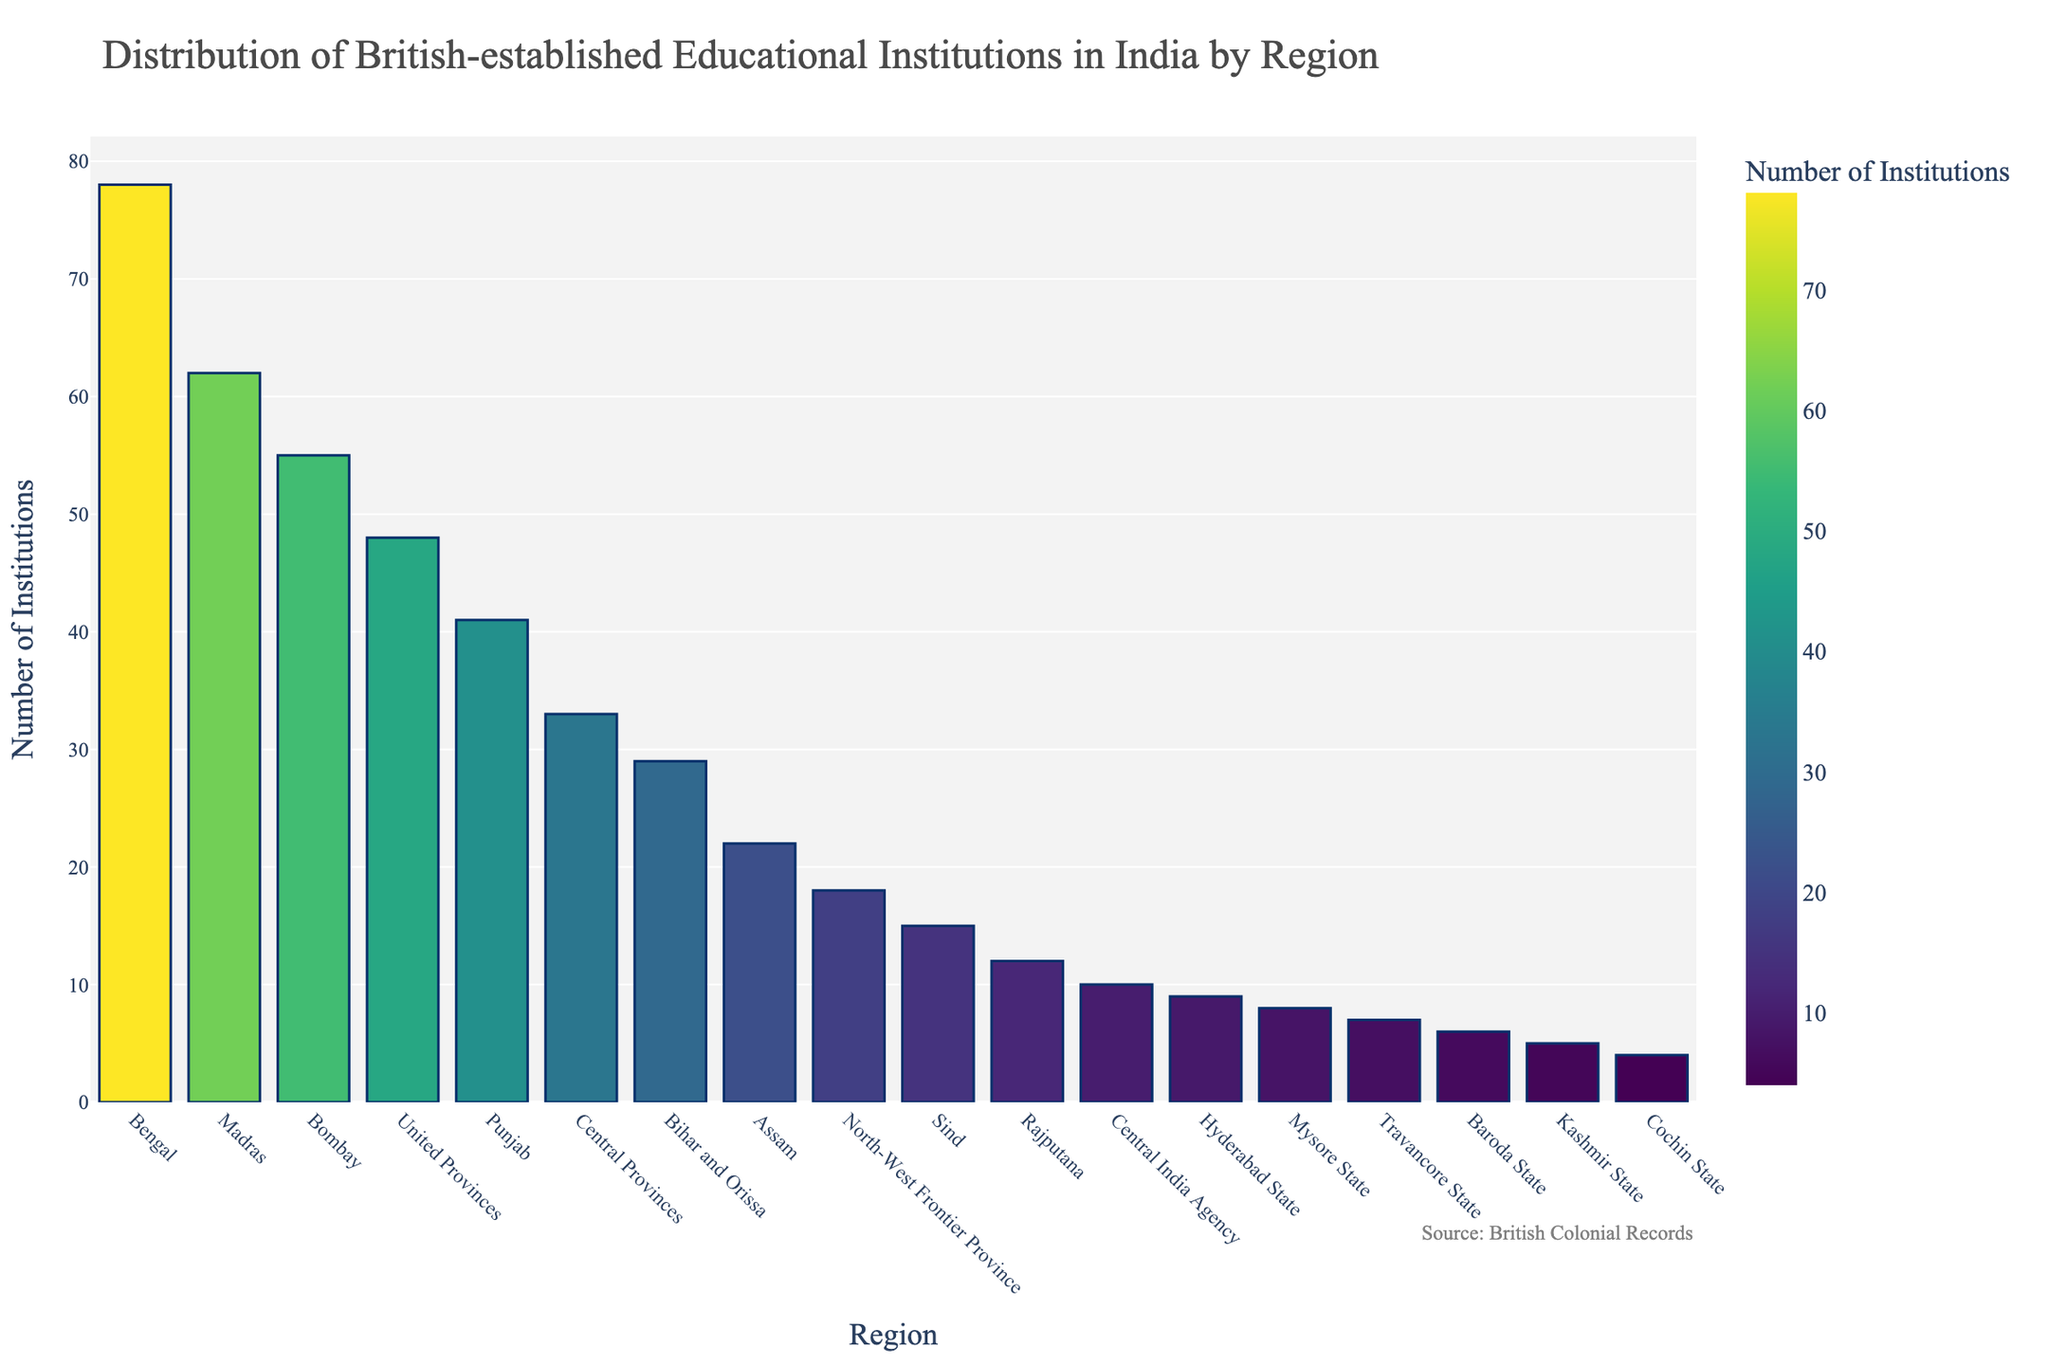Which region has the highest number of British-established educational institutions? To determine the region with the highest number of institutions, look at the bar chart and identify the tallest bar. The tallest bar represents the Bengal region.
Answer: Bengal Which region has the lowest number of British-established educational institutions? To find the region with the lowest number of institutions, identify the shortest bar on the chart. The shortest bar represents the Cochin State.
Answer: Cochin State How many more institutions does Bengal have compared to Punjab? Subtract the number of institutions in Punjab from the number in Bengal. Bengal has 78 institutions, and Punjab has 41. So, 78 - 41 = 37.
Answer: 37 What is the total number of educational institutions established in Bengal, Madras, and Bombay regions? Add the number of institutions in the Bengal, Madras, and Bombay regions. Bengal has 78, Madras has 62, and Bombay has 55. So, 78 + 62 + 55 = 195.
Answer: 195 Which regions have fewer than 10 British-established educational institutions? Look for bars that have a value less than 10. The regions are Hyderabad State, Mysore State, Travancore State, Baroda State, Kashmir State, and Cochin State.
Answer: Hyderabad State, Mysore State, Travancore State, Baroda State, Kashmir State, and Cochin State How many institutions were established in regions with more than 50 institutions? Identify bars with values greater than 50 and sum their counts. The regions are Bengal (78), Madras (62), and Bombay (55). So, 78 + 62 + 55 = 195.
Answer: 195 Which state has a number of institutions closest to the average of all states? First, calculate the average number of institutions: (78+62+55+48+41+33+29+22+18+15+12+10+9+8+7+6+5+4)/18 ≈ 26.56. The state closest to this average is Bihar and Orissa with 29 institutions.
Answer: Bihar and Orissa Is the number of institutions in Assam more or less than the median number of institutions across all regions? To determine the median, order the numbers and find the middle value. With 18 regions, the median is the average of the 9th and 10th values: (18+15)/2 = 16.5. Assam has 22 institutions, which is more than the median.
Answer: More Compare the total number of institutions in the United Provinces and Punjab regions with the total in Madras. Which is greater? Add the numbers for United Provinces (48) and Punjab (41), then compare with Madras (62). The total is 48 + 41 = 89, which is greater than 62.
Answer: United Provinces and Punjab 